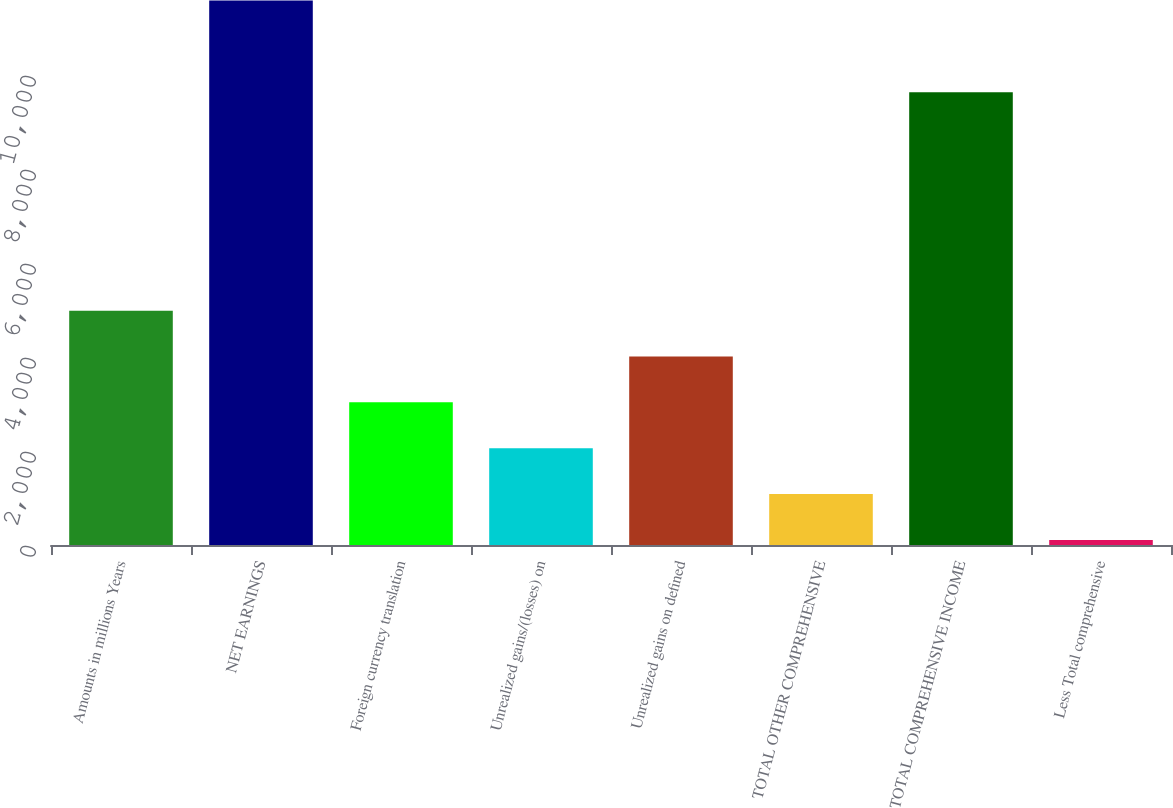Convert chart. <chart><loc_0><loc_0><loc_500><loc_500><bar_chart><fcel>Amounts in millions Years<fcel>NET EARNINGS<fcel>Foreign currency translation<fcel>Unrealized gains/(losses) on<fcel>Unrealized gains on defined<fcel>TOTAL OTHER COMPREHENSIVE<fcel>TOTAL COMPREHENSIVE INCOME<fcel>Less Total comprehensive<nl><fcel>4985<fcel>11583.4<fcel>3034.6<fcel>2059.4<fcel>4009.8<fcel>1084.2<fcel>9633<fcel>109<nl></chart> 